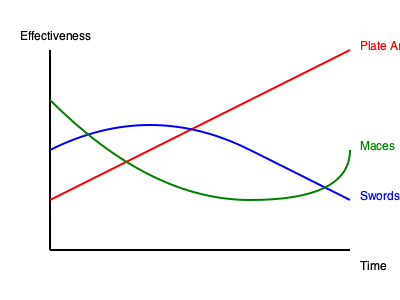Based on the graph depicting the effectiveness of medieval weapons and armor over time, which weapon type shows a resurgence in effectiveness during the late medieval period, likely as a counter to the increasing use of plate armor? To answer this question, we need to analyze the trends shown in the graph:

1. The red line represents plate armor, which shows increasing effectiveness over time.
2. The blue line represents swords, which show decreasing effectiveness in the later period.
3. The green line represents maces, which show an initial decline followed by an increase in effectiveness.

Step-by-step analysis:
1. Plate armor (red line) becomes increasingly effective over time, indicating improved protection for soldiers.
2. Swords (blue line) become less effective in the later period, likely due to their inability to penetrate plate armor easily.
3. Maces (green line) show a unique trend:
   a. Initial decline in effectiveness, possibly due to improved armor.
   b. Resurgence in effectiveness during the late medieval period.

The resurgence of maces can be attributed to their ability to cause damage through blunt force, even against plate armor. Unlike swords, which rely on cutting or piercing, maces could dent armor and cause concussive damage to the wearer.

This trend aligns with historical evidence that shows an increased use of blunt weapons like maces and war hammers in response to the widespread adoption of plate armor in the late medieval period.
Answer: Maces 